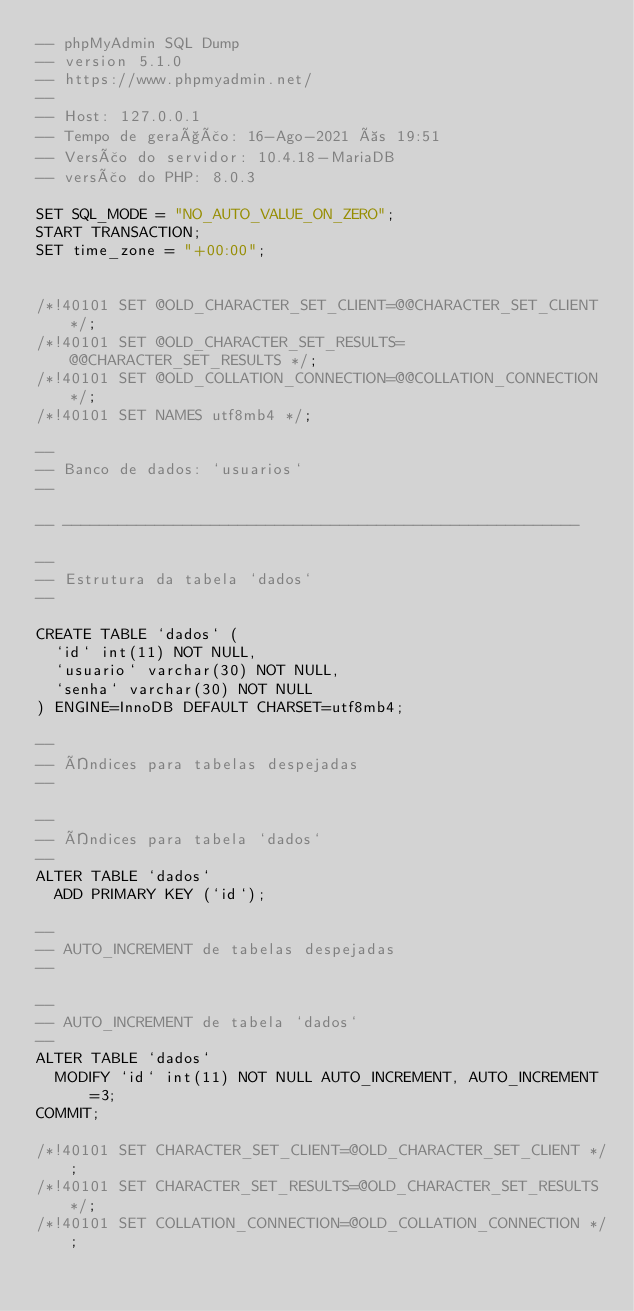<code> <loc_0><loc_0><loc_500><loc_500><_SQL_>-- phpMyAdmin SQL Dump
-- version 5.1.0
-- https://www.phpmyadmin.net/
--
-- Host: 127.0.0.1
-- Tempo de geração: 16-Ago-2021 às 19:51
-- Versão do servidor: 10.4.18-MariaDB
-- versão do PHP: 8.0.3

SET SQL_MODE = "NO_AUTO_VALUE_ON_ZERO";
START TRANSACTION;
SET time_zone = "+00:00";


/*!40101 SET @OLD_CHARACTER_SET_CLIENT=@@CHARACTER_SET_CLIENT */;
/*!40101 SET @OLD_CHARACTER_SET_RESULTS=@@CHARACTER_SET_RESULTS */;
/*!40101 SET @OLD_COLLATION_CONNECTION=@@COLLATION_CONNECTION */;
/*!40101 SET NAMES utf8mb4 */;

--
-- Banco de dados: `usuarios`
--

-- --------------------------------------------------------

--
-- Estrutura da tabela `dados`
--

CREATE TABLE `dados` (
  `id` int(11) NOT NULL,
  `usuario` varchar(30) NOT NULL,
  `senha` varchar(30) NOT NULL
) ENGINE=InnoDB DEFAULT CHARSET=utf8mb4;

--
-- Índices para tabelas despejadas
--

--
-- Índices para tabela `dados`
--
ALTER TABLE `dados`
  ADD PRIMARY KEY (`id`);

--
-- AUTO_INCREMENT de tabelas despejadas
--

--
-- AUTO_INCREMENT de tabela `dados`
--
ALTER TABLE `dados`
  MODIFY `id` int(11) NOT NULL AUTO_INCREMENT, AUTO_INCREMENT=3;
COMMIT;

/*!40101 SET CHARACTER_SET_CLIENT=@OLD_CHARACTER_SET_CLIENT */;
/*!40101 SET CHARACTER_SET_RESULTS=@OLD_CHARACTER_SET_RESULTS */;
/*!40101 SET COLLATION_CONNECTION=@OLD_COLLATION_CONNECTION */;
</code> 